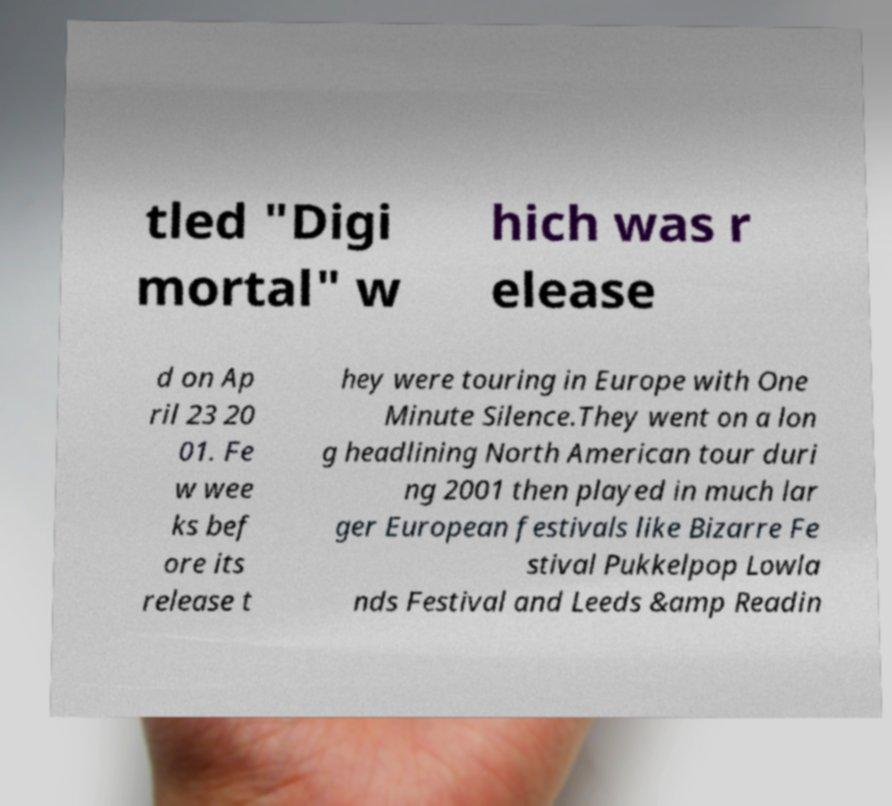I need the written content from this picture converted into text. Can you do that? tled "Digi mortal" w hich was r elease d on Ap ril 23 20 01. Fe w wee ks bef ore its release t hey were touring in Europe with One Minute Silence.They went on a lon g headlining North American tour duri ng 2001 then played in much lar ger European festivals like Bizarre Fe stival Pukkelpop Lowla nds Festival and Leeds &amp Readin 